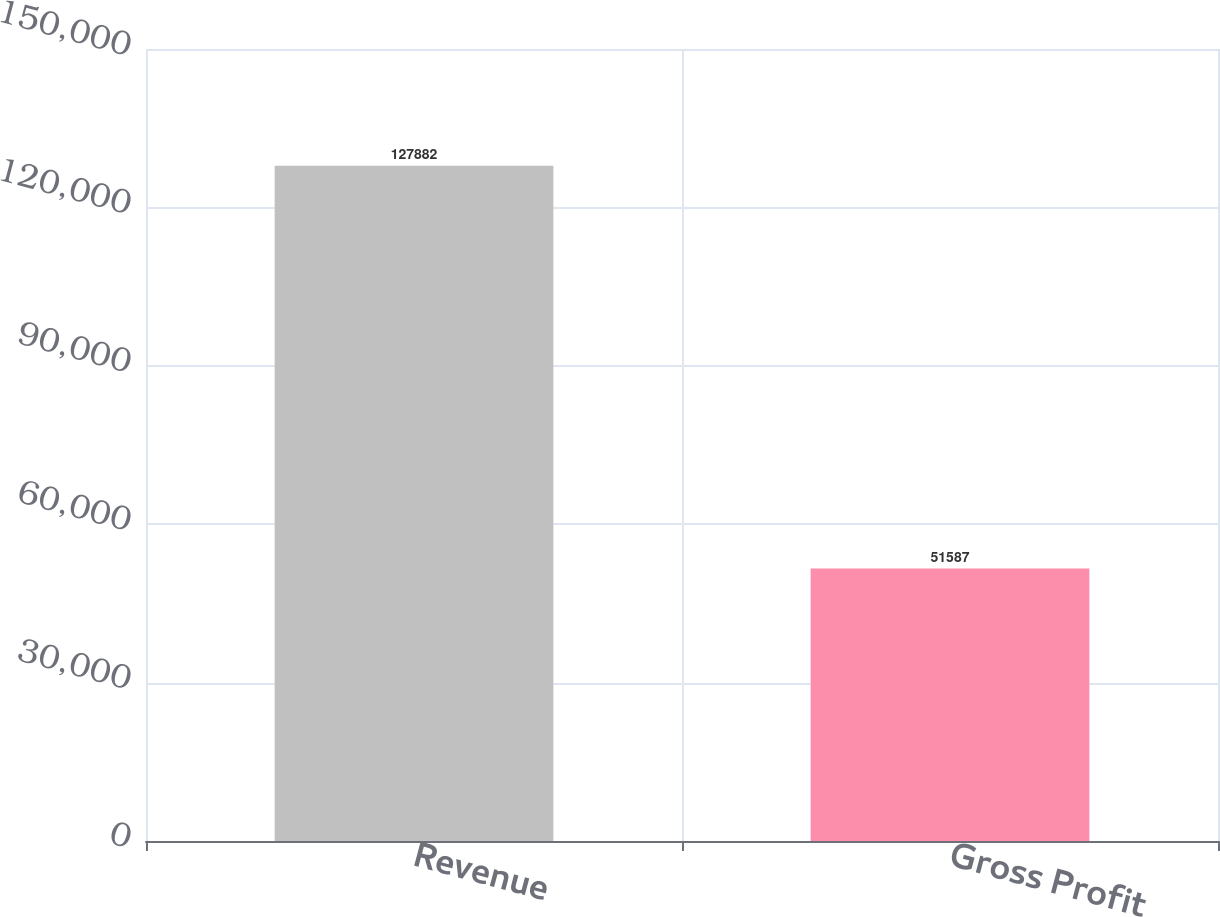Convert chart to OTSL. <chart><loc_0><loc_0><loc_500><loc_500><bar_chart><fcel>Revenue<fcel>Gross Profit<nl><fcel>127882<fcel>51587<nl></chart> 